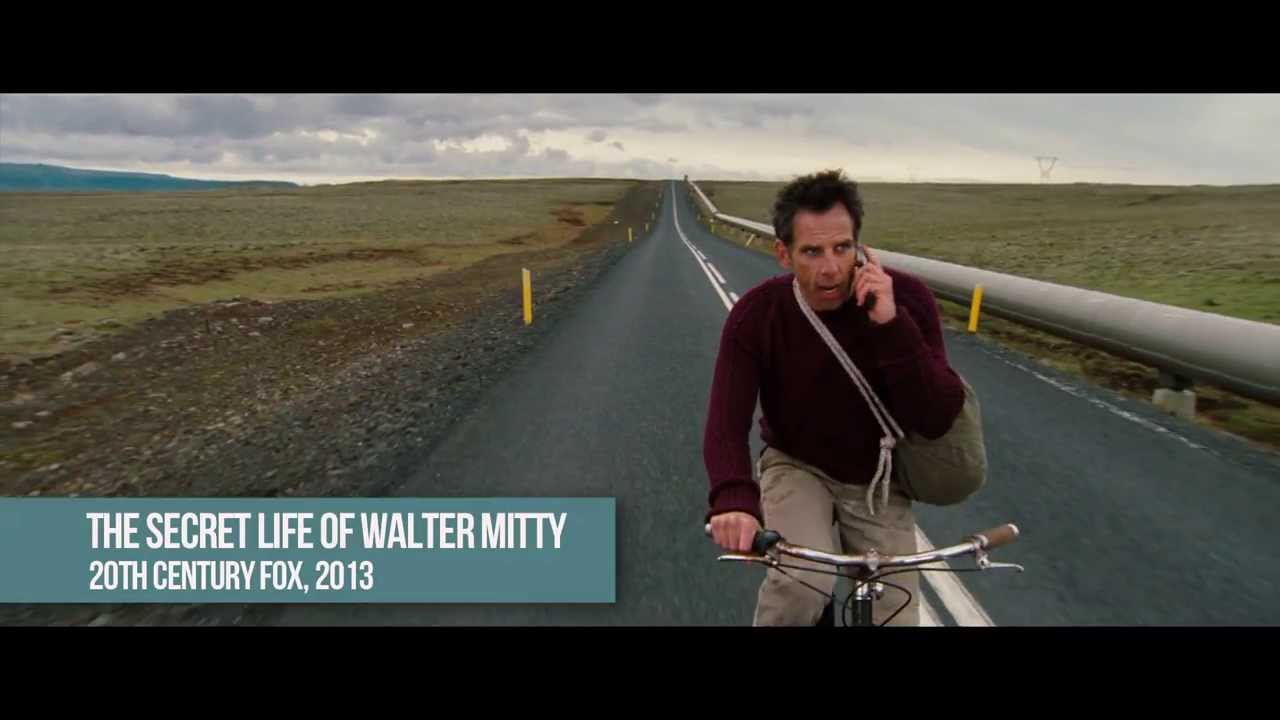What emotions does this image evoke, and why? The image evokes feelings of solitude and contemplation, enhanced by the expansive, empty landscape and the overcast sky. The man's focused expression and solo activity on a remote road contribute to a sense of isolation and introspection. Can you describe any symbolic meanings that might be encapsulated in this setting? The long, straight road could symbolize a journey, not just physical but also emotional or spiritual. The barren landscape might represent simplicity and a stripping away of non-essential elements, focusing on bare realities. The solitary figure might symbolize personal or internal challenges, suggesting a narrative of overcoming or enduring. 